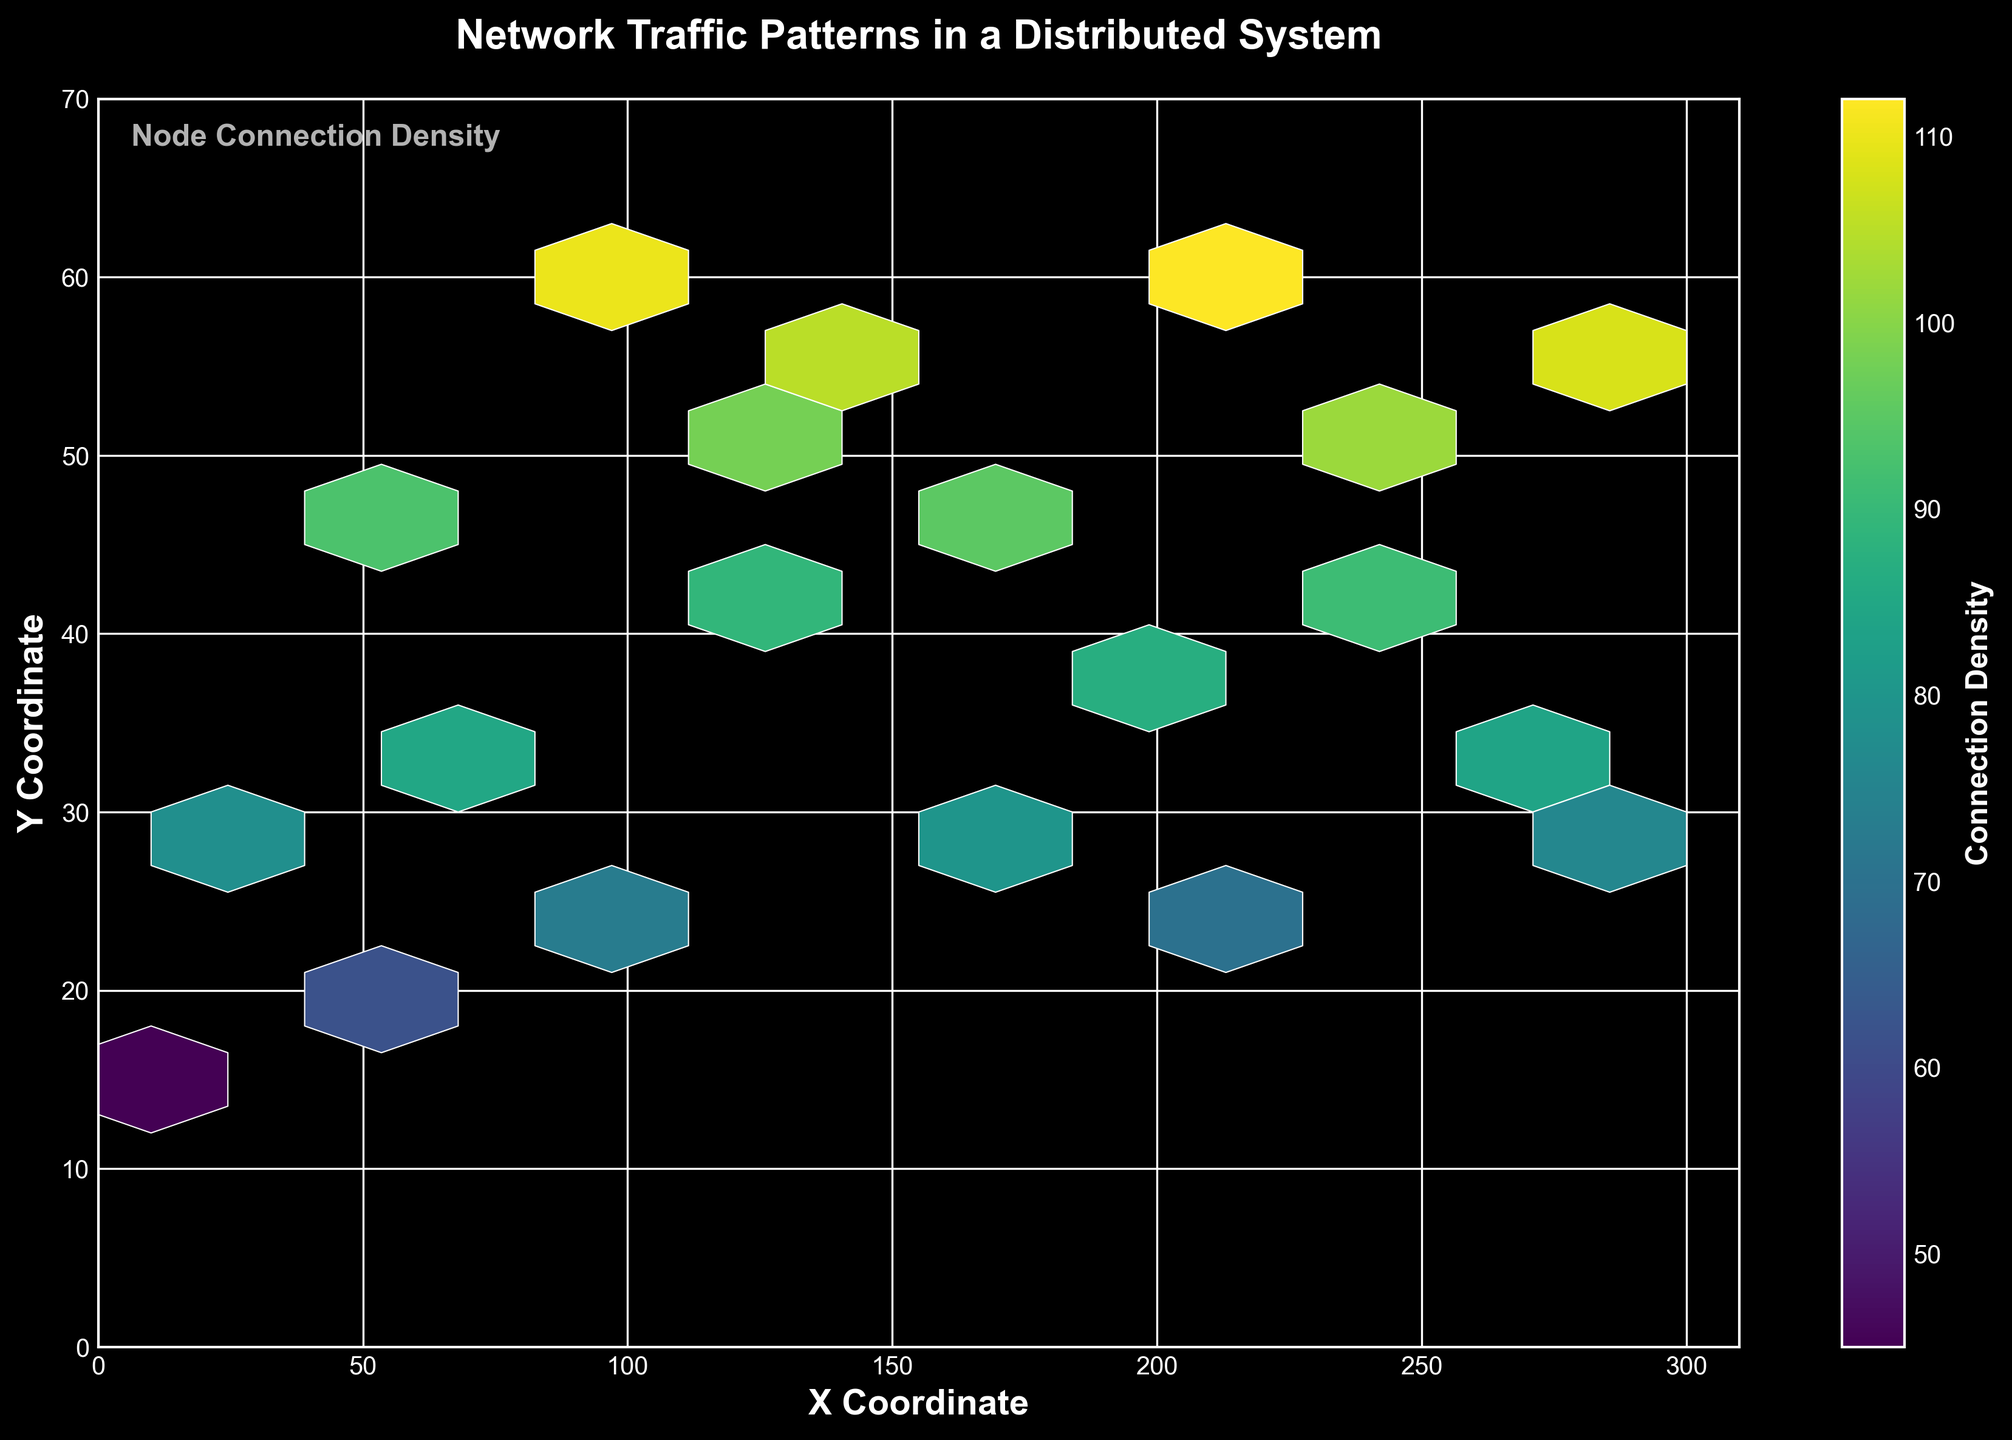What is the color scheme used in the plot? The color scheme used in the figure is 'viridis', which typically transitions from dark (blue/purple) to bright (yellow/green). You can see these corresponding colors in the hexagons representing different connection densities.
Answer: 'viridis' What are the labels of the x and y axes? The x-axis is labeled "X Coordinate" and the y-axis is labeled "Y Coordinate", as can be seen on the respective sides of the plot.
Answer: X Coordinate, Y Coordinate What is the range of the x-axis and y-axis? The x-axis ranges from 0 to 310 and the y-axis ranges from 0 to 70, as indicated by the axis labels and tick marks.
Answer: 0-310, 0-70 Which region (x,y) has the highest connection density? The region around coordinates (210, 60) has the highest connection density, as indicated by the brightest yellow/green hexagon on the plot.
Answer: Near (210, 60) How many data bins are represented on the hexbin plot? The plot has a "gridsize=10", resulting in 100 hexagonal bins. Each hexagon represents a bin within this grid size.
Answer: 100 Where does the connection density appear to be the lowest? The connection density appears to be the lowest around the coordinate (10, 15), as indicated by a darker (blue/purple) hexagon.
Answer: Near (10, 15) Is there a noticeable trend in connection density moving from left to right on the x-axis? Yes, there is a noticeable trend. The connection density generally increases as you move from left (lower x-values) to right (higher x-values), peaking around the middle x-values (around 210), and then slightly decreases towards the far right.
Answer: Yes Which areas have medium connection densities? The areas around (55, 45) and (150, 55) show medium connection densities, indicated by greenish hexagons.
Answer: Near (55, 45) and (150, 55) What does the figure title convey about the plot? The figure title "Network Traffic Patterns in a Distributed System" indicates that the plot is visualizing how network traffic varies across different regions in a distributed system, with a focus on connection density.
Answer: Network Traffic Patterns in a Distributed System How does the color bar help in interpreting the plot? The color bar on the right side of the plot provides a scale for connection densities, making it easy to map the color of hexagons to specific density values. Higher densities are in the yellow/green range, while lower densities are in the blue/purple range.
Answer: It provides scale for connection densities 